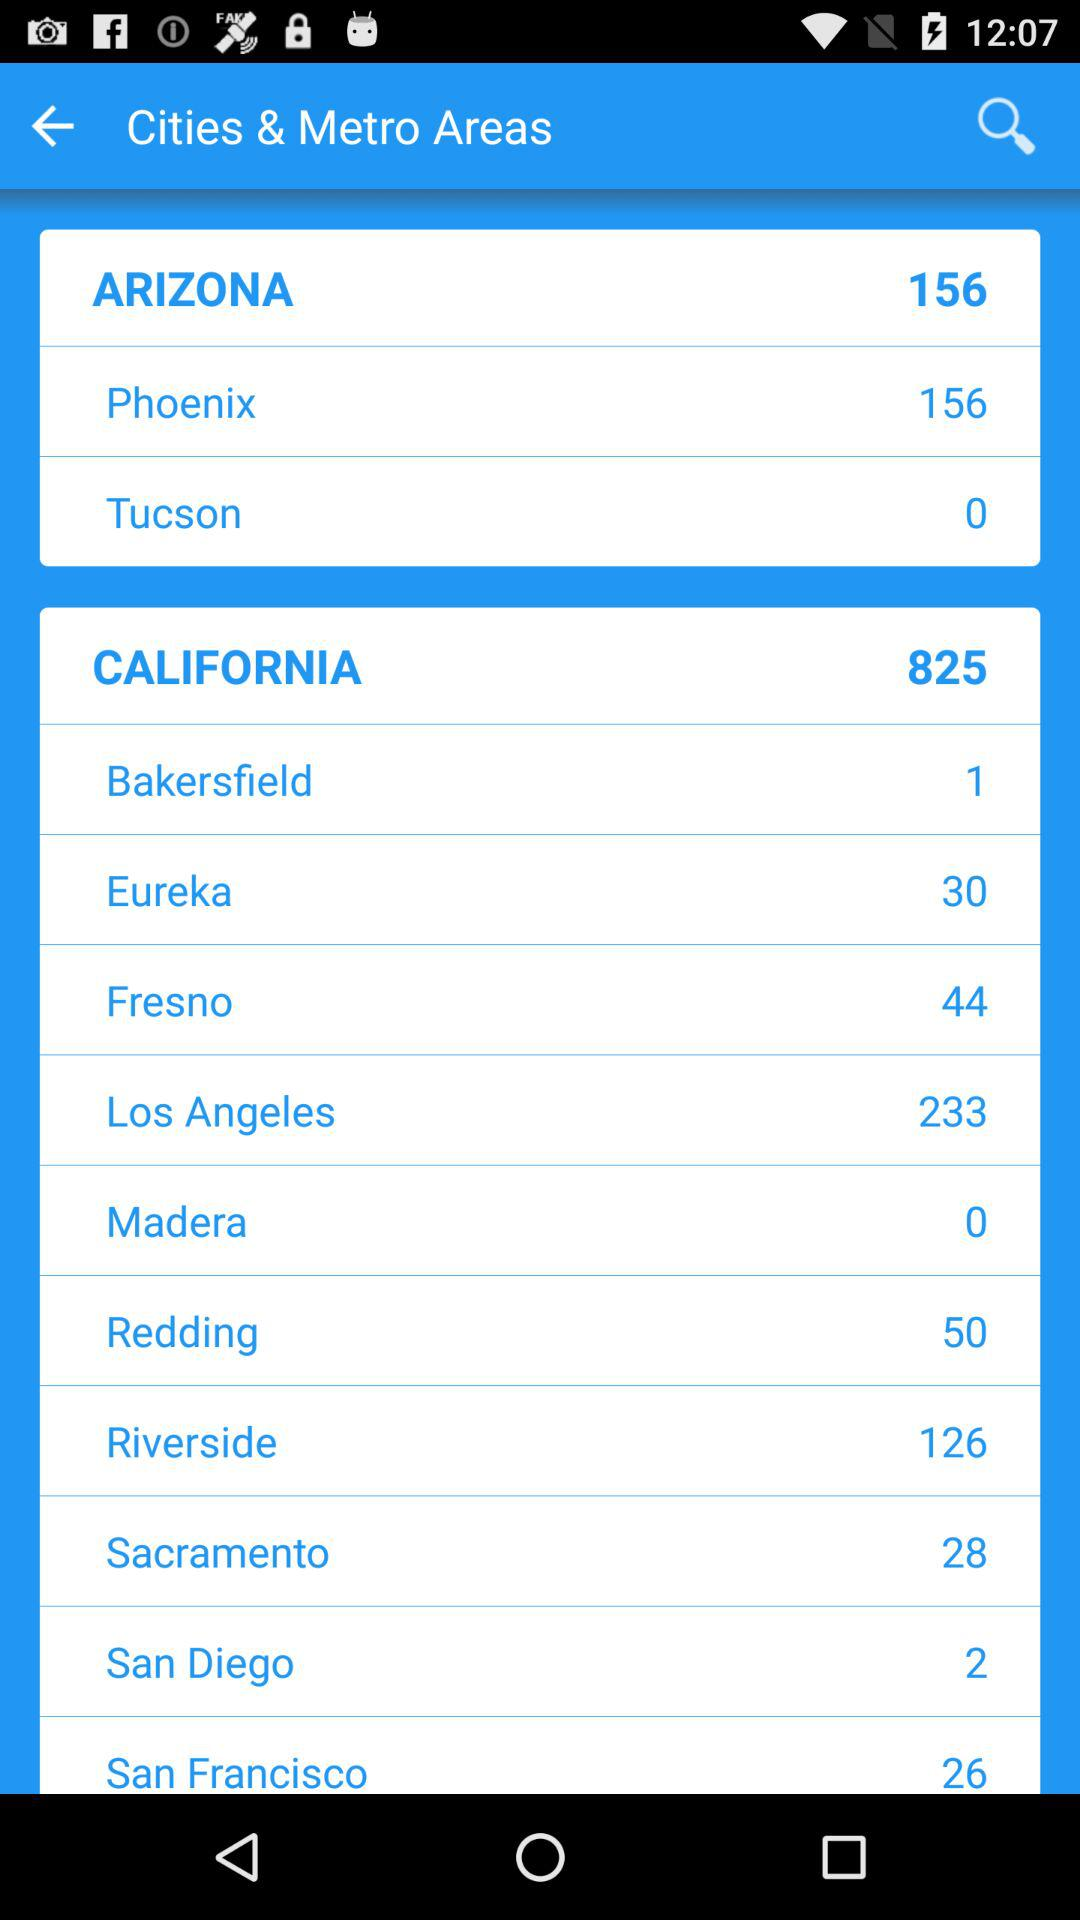How many areas in Phoenix? There are 156 areas in Phoenix. 